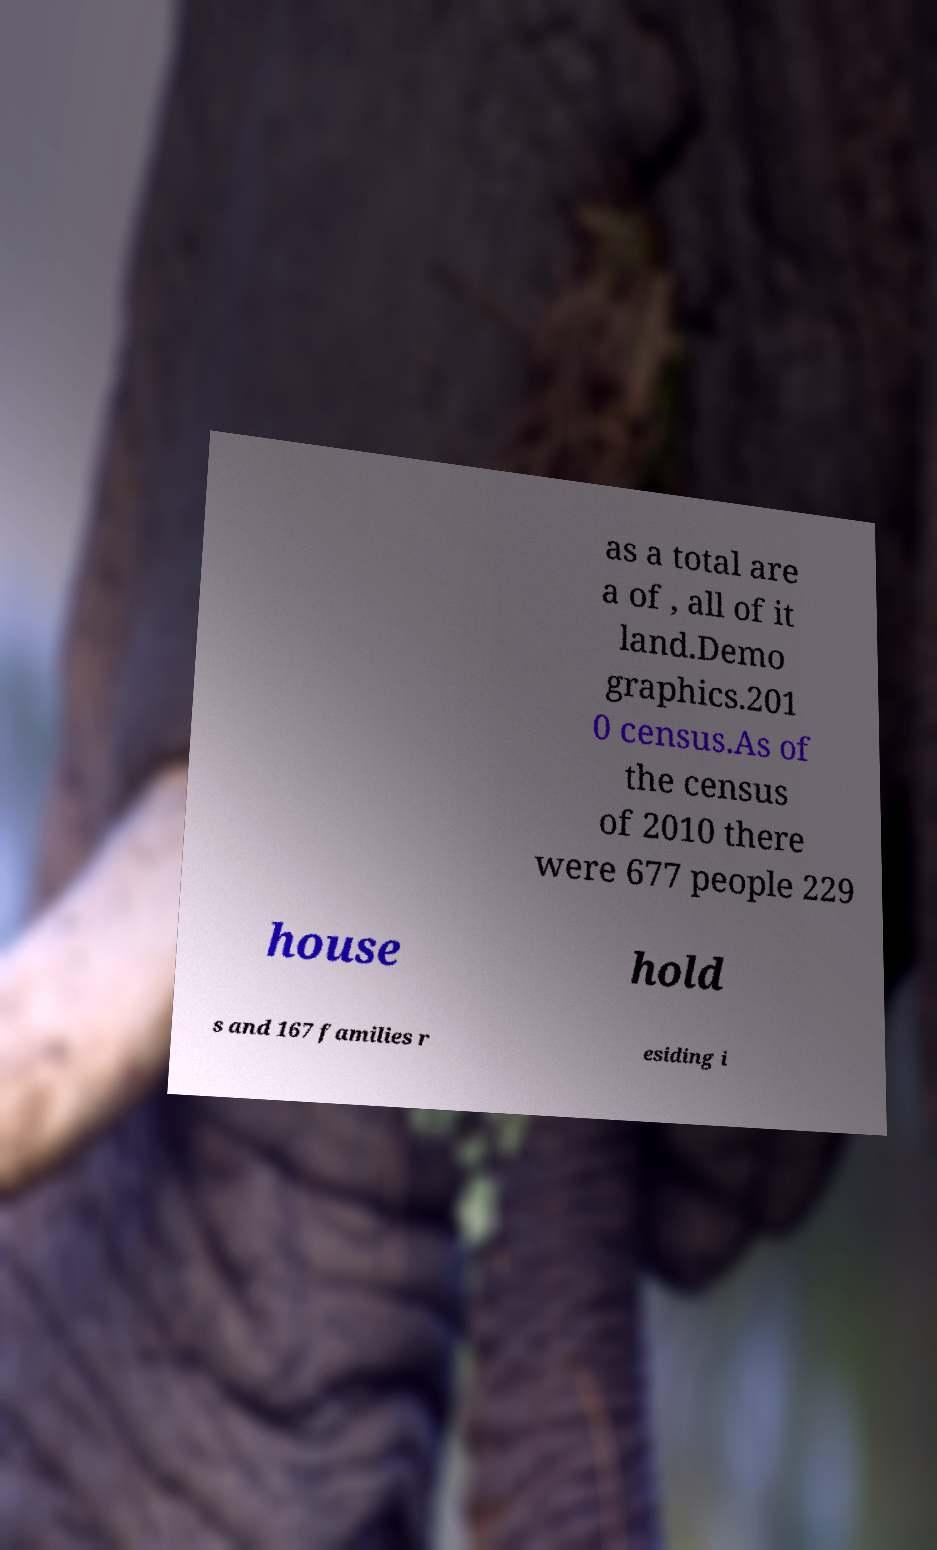Please identify and transcribe the text found in this image. as a total are a of , all of it land.Demo graphics.201 0 census.As of the census of 2010 there were 677 people 229 house hold s and 167 families r esiding i 